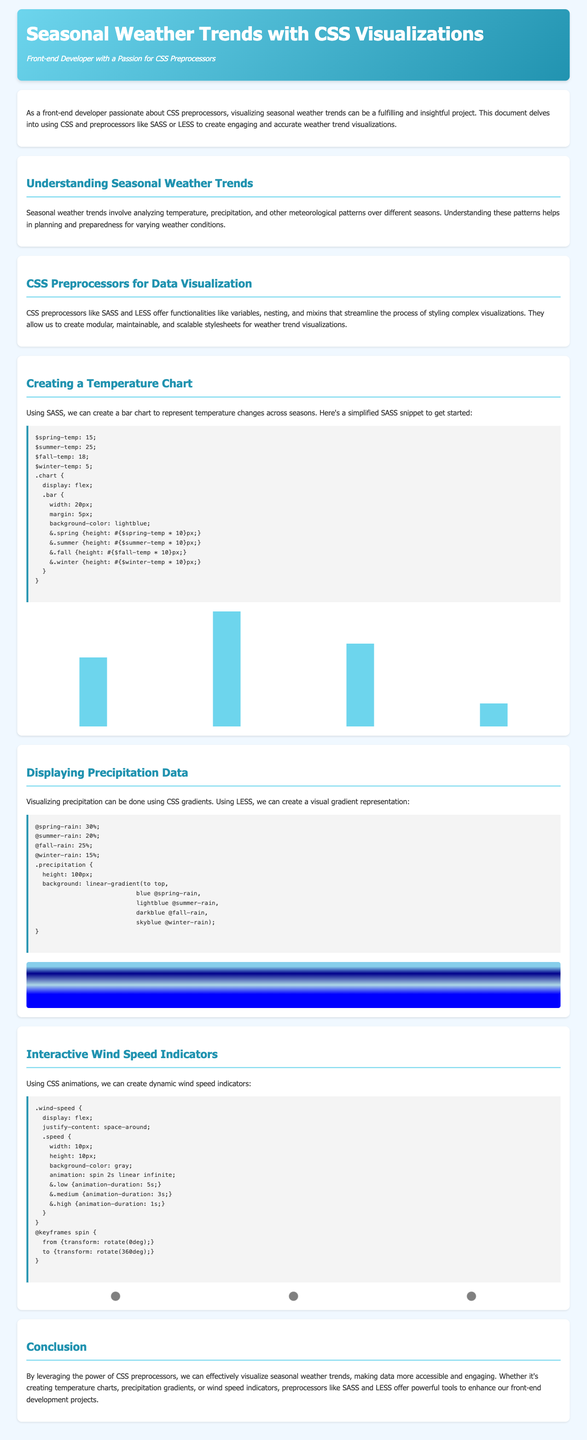What is the title of the document? The title of the document is given in the `<title>` tag, which is "Seasonal Weather Trends with CSS Visualizations."
Answer: Seasonal Weather Trends with CSS Visualizations What season has the highest temperature bar? The height of the bars in the chart visually indicates temperature for each season, and summer has the tallest bar.
Answer: Summer What CSS preprocessor is mentioned for creating visualizations? The document mentions SASS and LESS as CSS preprocessors for creating visualizations.
Answer: SASS and LESS How tall is the winter temperature bar? The height of the winter bar is specified in the CSS as 50 pixels.
Answer: 50 pixels Which season represents the second-highest total precipitation in the document? The precipitation representation indicates the values for each season, and fall has the second-highest value.
Answer: Fall What are the color themes used in the header section? The header section features a gradient blending from a light blue to a darker blue, specifically #6dd5ed to #2193b0.
Answer: Light blue to dark blue What is the animation speed for high wind speed indicators? The document specifies that the animation duration for high wind speed indicators is set to 1 second.
Answer: 1 second How many seasons are displayed in the temperature chart? The temperature chart visually represents four seasons: spring, summer, fall, and winter.
Answer: Four What background effect is used for the precipitation visualization? The precipitation visualization utilizes a linear gradient for its background effect.
Answer: Linear gradient 